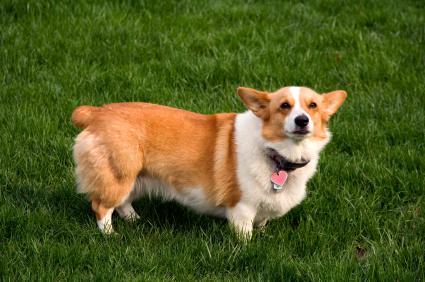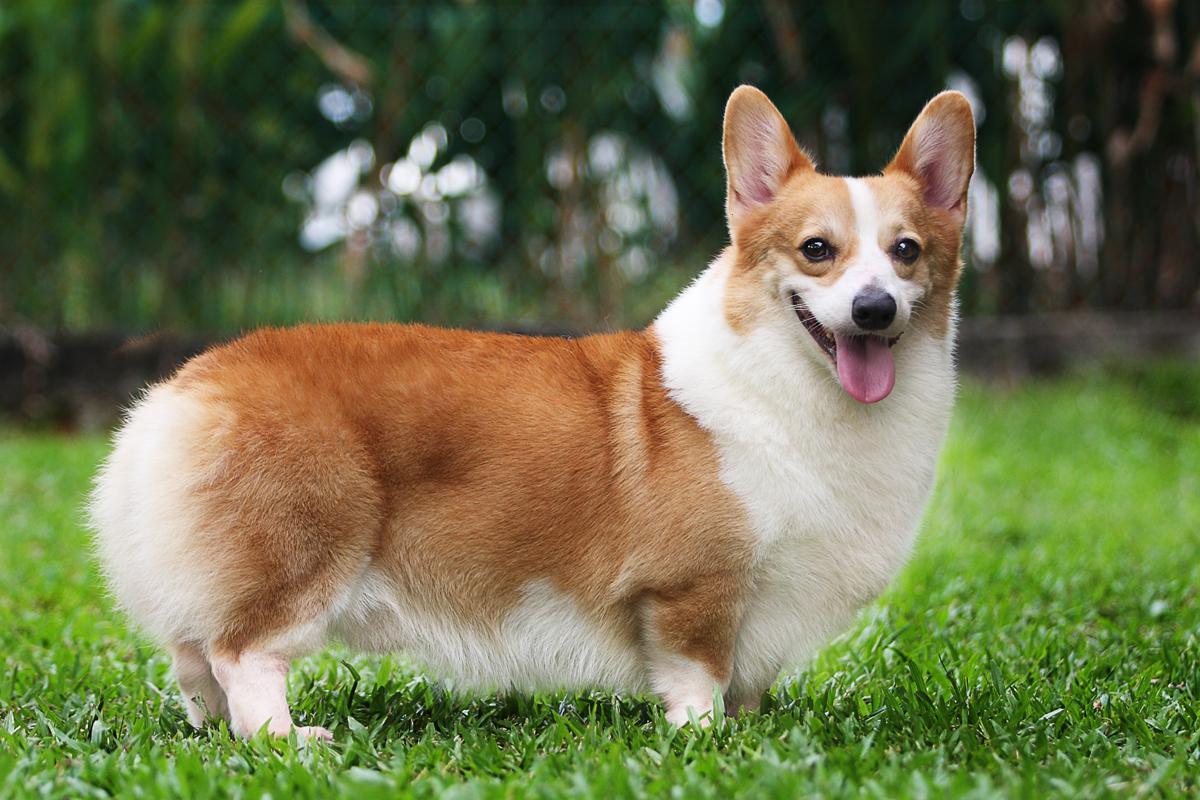The first image is the image on the left, the second image is the image on the right. For the images displayed, is the sentence "At least one dog is sitting." factually correct? Answer yes or no. No. 